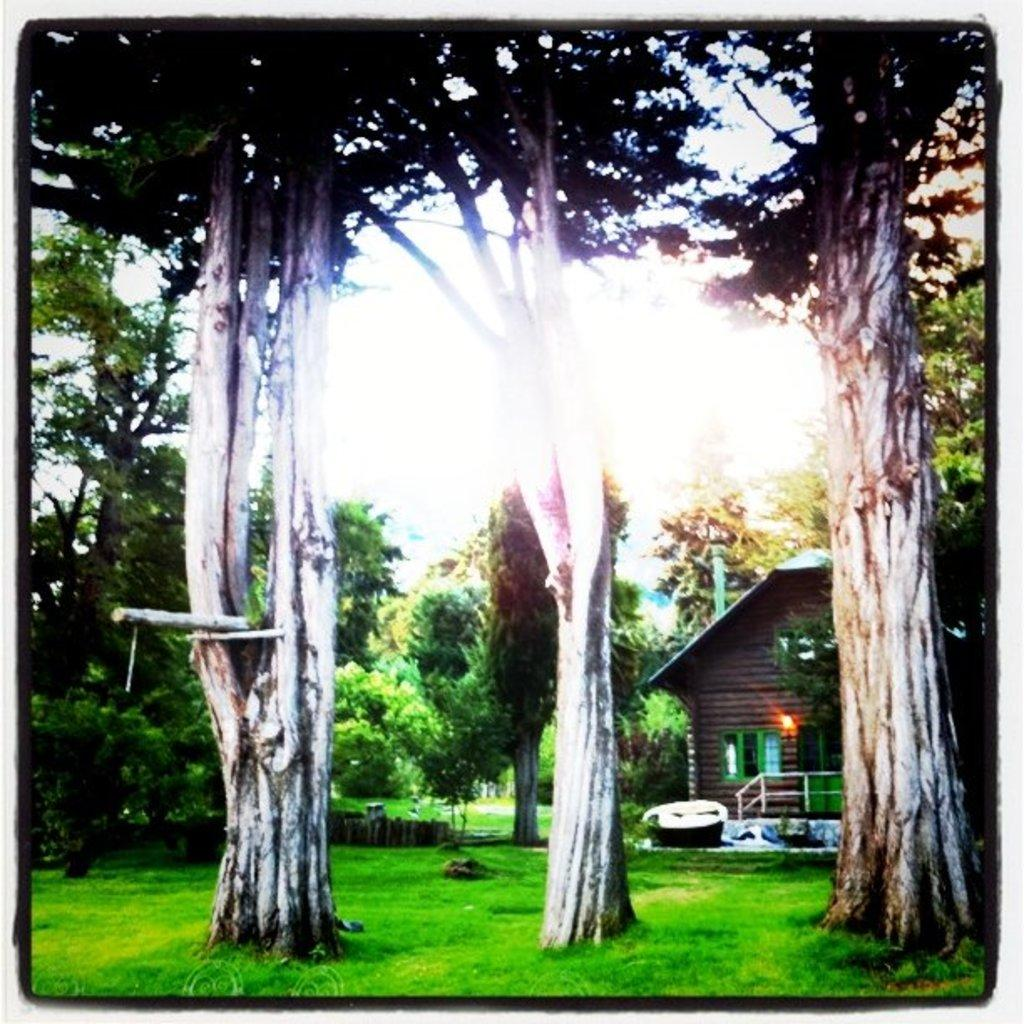What type of vegetation is in the center of the image? There are trees in the center of the image. What structure is located on the right side of the image? There is a shed on the right side of the image. What can be seen in the background of the image? The sky is visible in the background of the image. What type of ground cover is at the bottom of the image? There is grass at the bottom of the image. How many quinces are hanging from the trees in the image? There are no quinces present in the image; it only features trees. What type of weapon is the duck carrying in the image? There is no duck or weapon present in the image. 